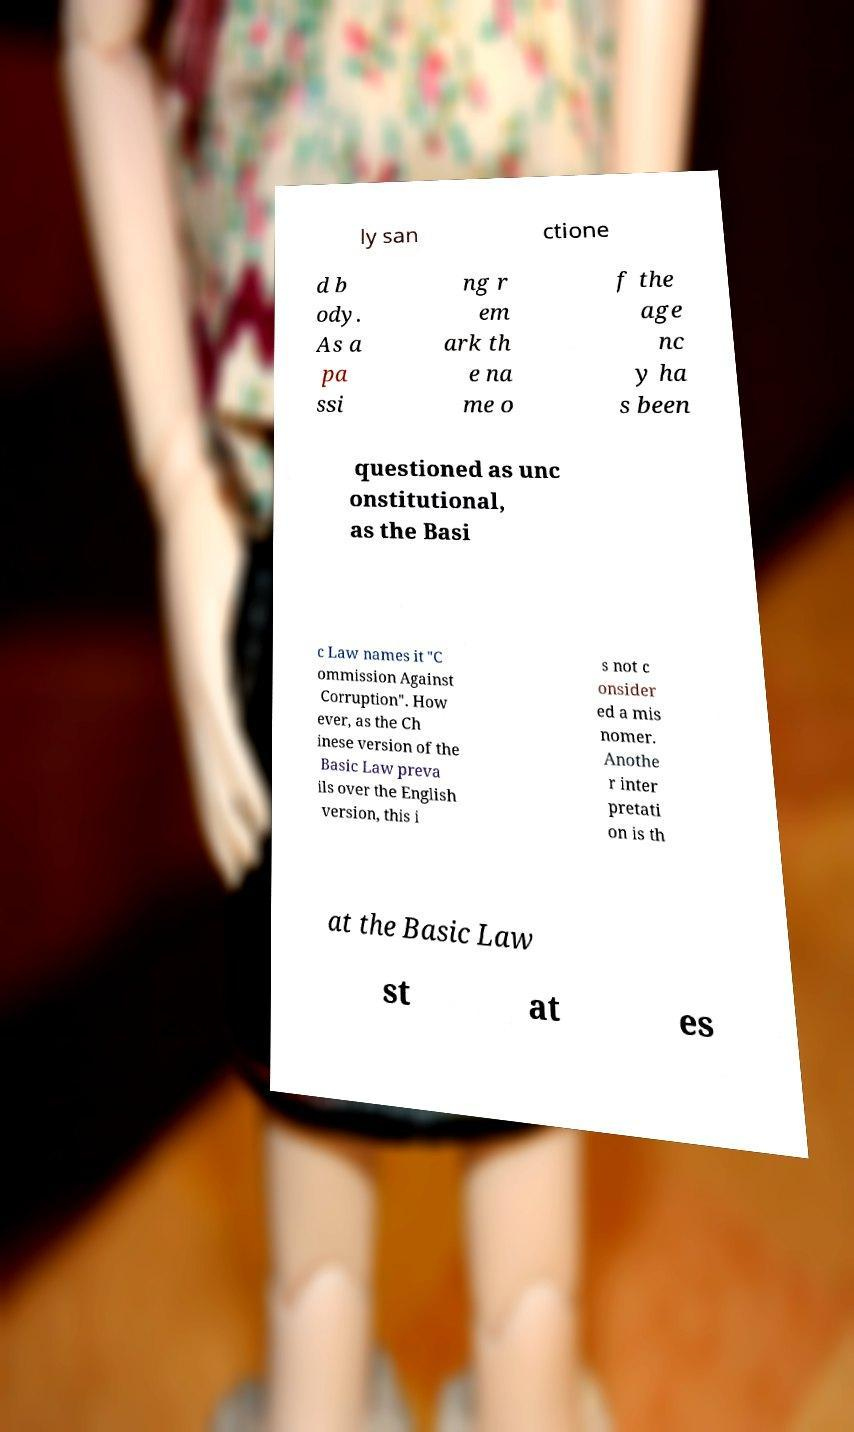What messages or text are displayed in this image? I need them in a readable, typed format. ly san ctione d b ody. As a pa ssi ng r em ark th e na me o f the age nc y ha s been questioned as unc onstitutional, as the Basi c Law names it "C ommission Against Corruption". How ever, as the Ch inese version of the Basic Law preva ils over the English version, this i s not c onsider ed a mis nomer. Anothe r inter pretati on is th at the Basic Law st at es 